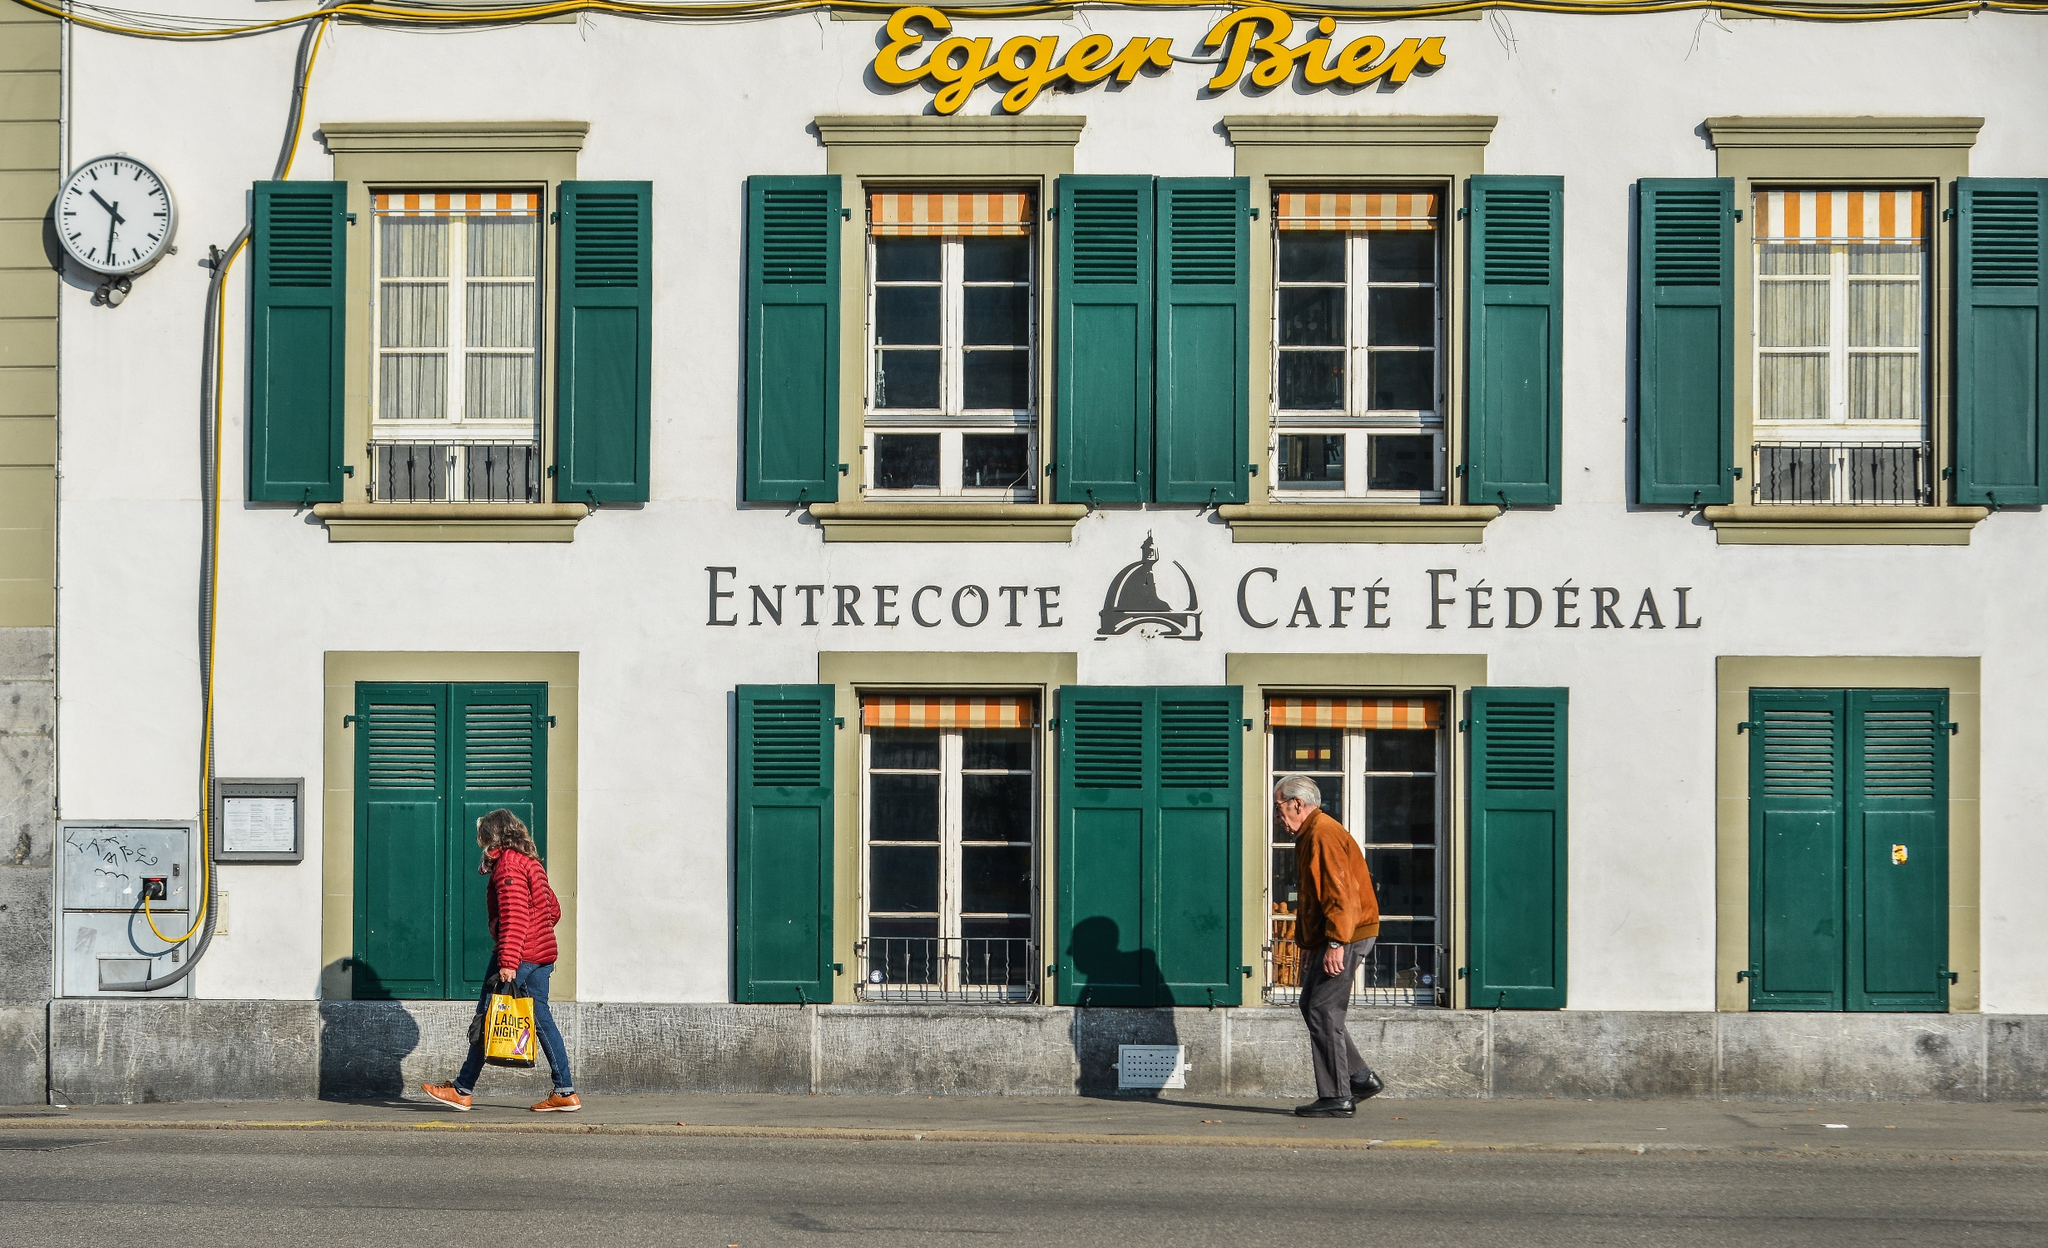What can you tell about the architectural style of the building? The architectural style of the building, housing 'Entrecote Café Fédéral', is quintessentially Swiss, characterized by its symmetric design, pristine white facade, and green shuttered windows. The shutters add both a functional element, protecting against the weather, and a decorative touch, reflecting traditional Swiss aesthetics. The clock on the left side of the building introduces a classical European element, signifying the importance of time and adding an air of timeless charm to the scene. 